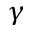Convert formula to latex. <formula><loc_0><loc_0><loc_500><loc_500>\gamma</formula> 